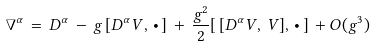<formula> <loc_0><loc_0><loc_500><loc_500>\nabla ^ { \alpha } \, = \, D ^ { \alpha } \, - \, g \, [ D ^ { \alpha } V , \, \bullet \, ] \, + \, \frac { g ^ { 2 } } { 2 } [ \, [ D ^ { \alpha } V , \, V ] , \, \bullet \, ] \, + O ( g ^ { 3 } )</formula> 